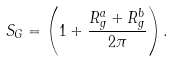<formula> <loc_0><loc_0><loc_500><loc_500>S _ { G } = \left ( 1 + \frac { R ^ { a } _ { g } + R ^ { b } _ { g } } { 2 \pi } \right ) .</formula> 